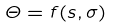<formula> <loc_0><loc_0><loc_500><loc_500>\Theta = f ( s , \sigma )</formula> 